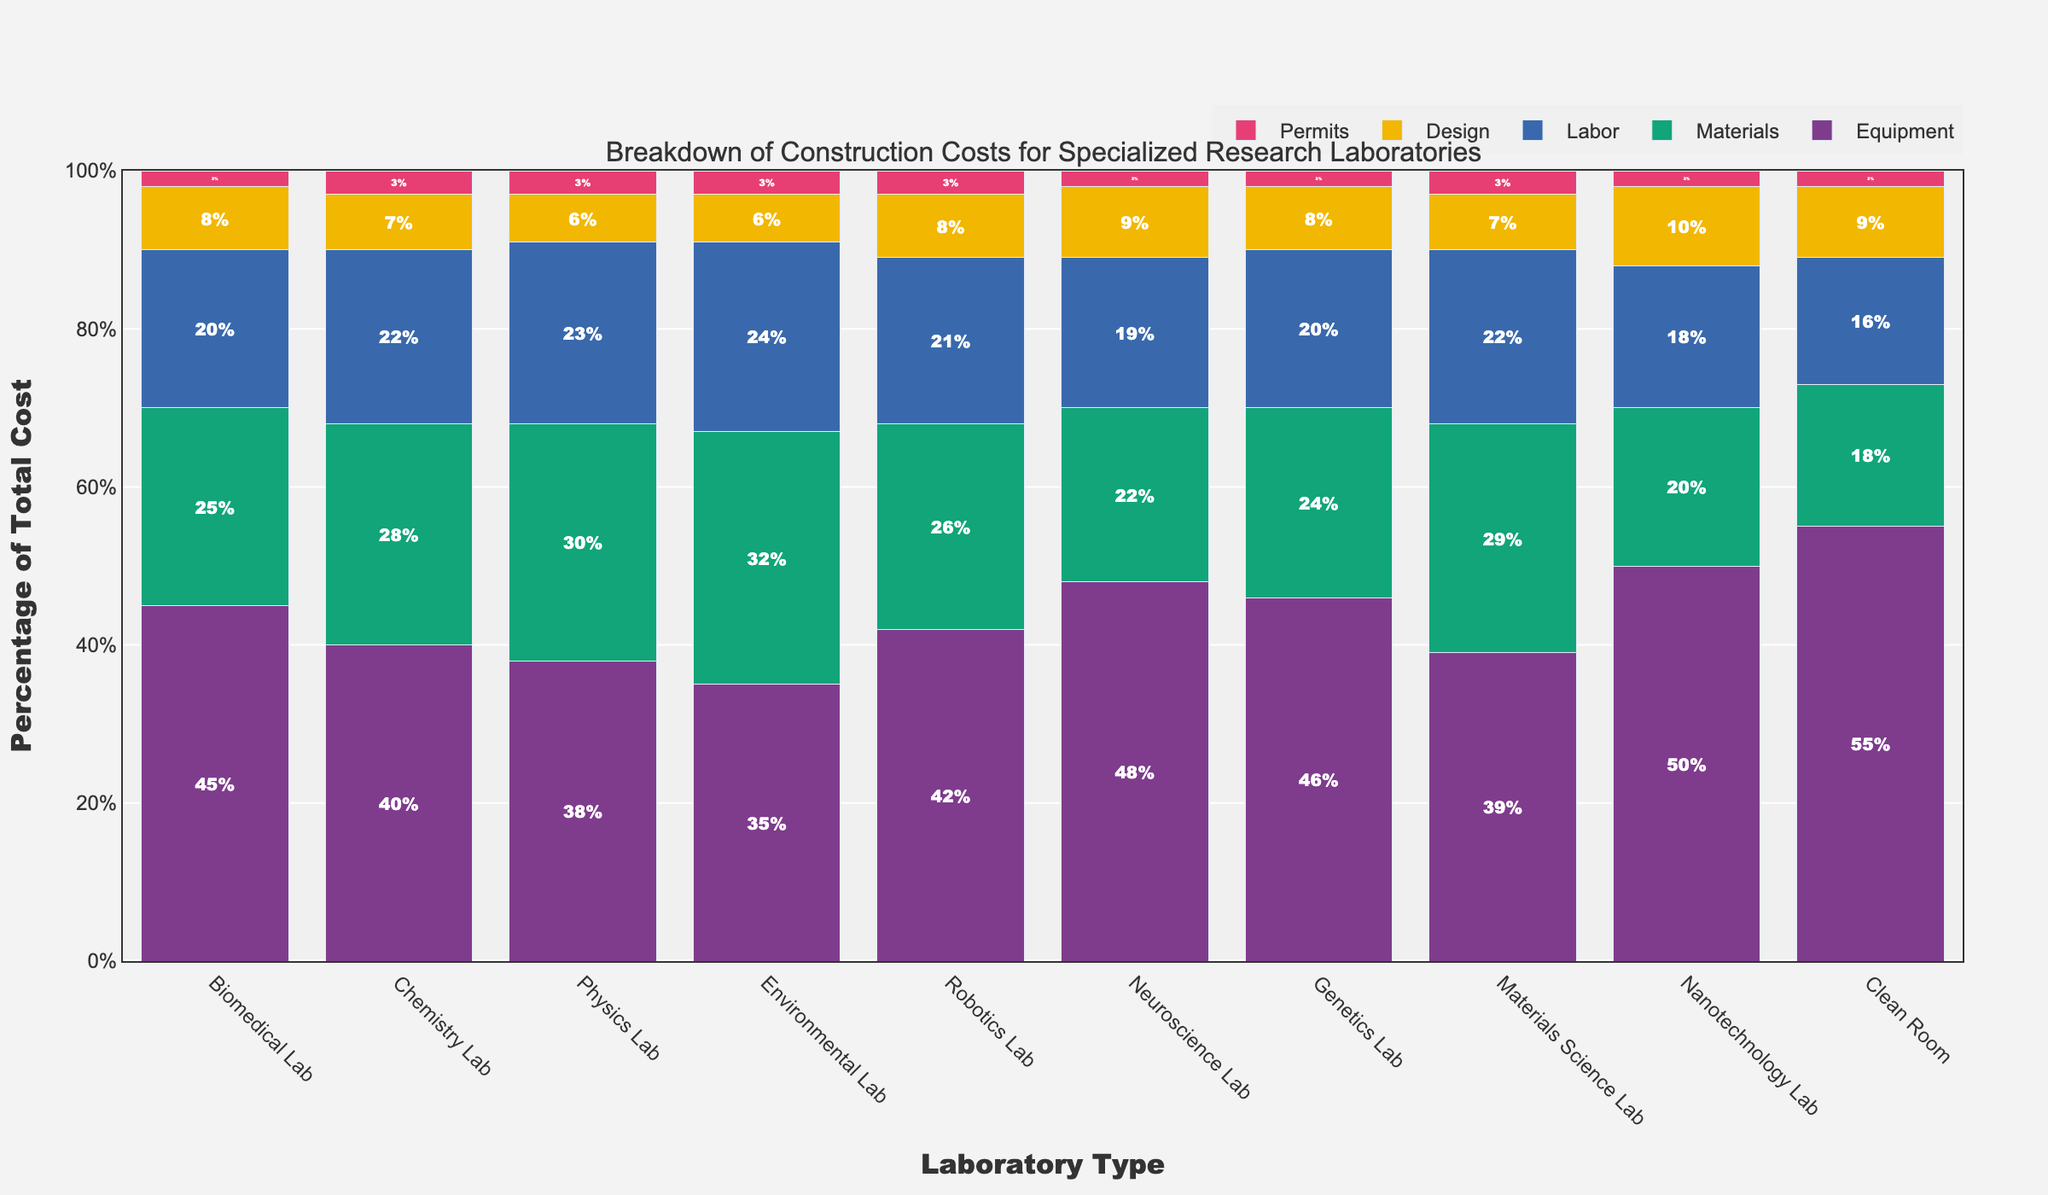What type of laboratory has the highest cost percentage for Equipment? Look at the data in the figure and identify which laboratory type has the tallest bar for Equipment. The Nanotechnology Lab has the tallest bar for Equipment at 50%.
Answer: Nanotechnology Lab Which laboratory type has the lowest percentage for Labor costs? Compare the height of the bars representing Labor costs for each laboratory type and find the shortest one. The Clean Room has the shortest bar for Labor costs at 16%.
Answer: Clean Room What is the combined percentage of Equipment and Materials costs for the Biomedical Lab? Add the percentages of Equipment and Materials costs for the Biomedical Lab: 45% (Equipment) + 25% (Materials) = 70%.
Answer: 70% How much higher is the percentage of Design costs for Nanotechnology Labs compared to Physics Labs? Subtract the Design costs percentage of the Physics Lab from the Nanotechnology Lab: 10% (Nanotechnology) - 6% (Physics) = 4%.
Answer: 4% Which laboratory type has the equal percentage for Materials, Labor, and Permits? Compare the height of the bars for Materials, Labor, and Permits for each laboratory type and find the one with equal heights. None of the laboratory types show this equality.
Answer: None Which lab type has the highest overall percentage for combined Design and Permits costs? Sum up the Design and Permits costs for all lab types and compare them. The Nanotechnology Lab has the highest combined Design (10%) and Permits (2%) costs at 12%.
Answer: Nanotechnology Lab What is the difference between the percentage of Materials costs for Environmental Labs and Neuroscience Labs? Subtract the Materials costs percentage of the Neuroscience Lab from the Environmental Lab: 32% (Environmental) - 22% (Neuroscience) = 10%.
Answer: 10% Which two laboratory types have the same percentage for Permits costs? Look for columns with the same height for the Permits costs. Biomedical Lab, Neuroscience Lab, Genetics Lab, Nanotechnology Lab, and Clean Room all have the same Permits costs percentage at 2%.
Answer: Biomedical Lab, Neuroscience Lab, Genetics Lab, Nanotechnology Lab, Clean Room What is the median percentage of Labor costs across all laboratory types? Arrange the Labor costs percentages in ascending order: [16, 18, 19, 20, 20, 21, 22, 22, 23, 24]. The middle two values are 20 and 21, so the median is (20 + 21) / 2 = 20.5%.
Answer: 20.5% What laboratory type has both the lowest percentage for Labor costs and the highest for Equipment costs? Identify the laboratory type with the lowest percentage for Labor costs and also check if it has the highest Equipment costs. Clean Room has the lowest Labor costs (16%) and has among the highest Equipment costs (55%).
Answer: Clean Room 